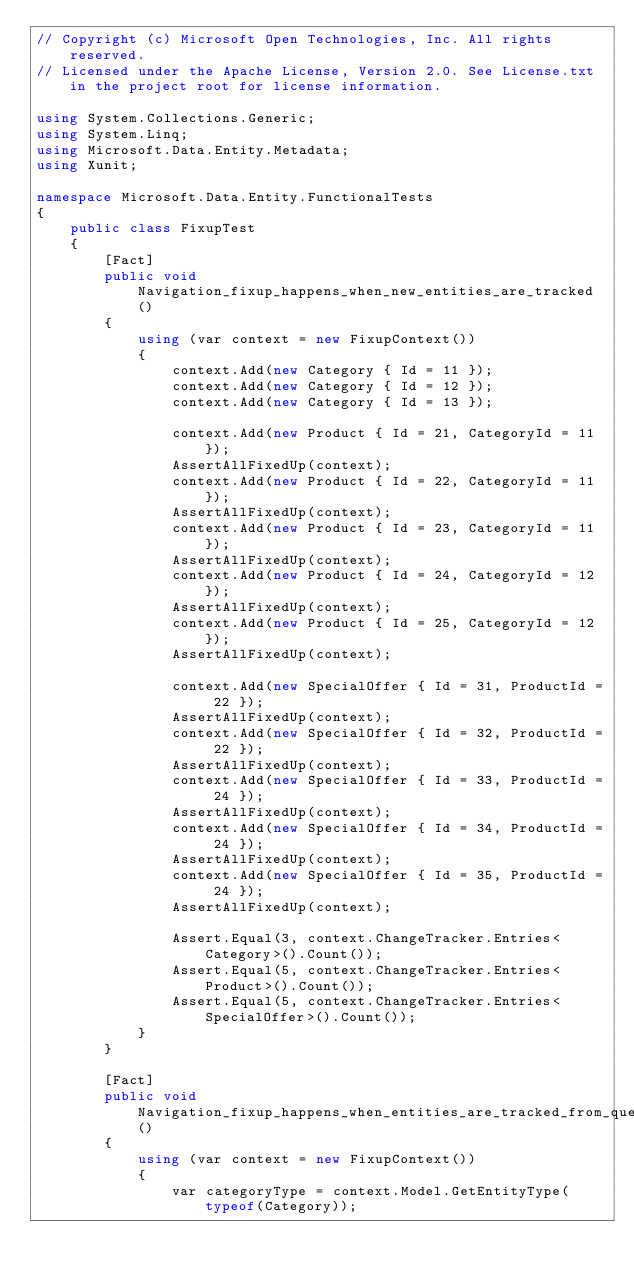Convert code to text. <code><loc_0><loc_0><loc_500><loc_500><_C#_>// Copyright (c) Microsoft Open Technologies, Inc. All rights reserved.
// Licensed under the Apache License, Version 2.0. See License.txt in the project root for license information.

using System.Collections.Generic;
using System.Linq;
using Microsoft.Data.Entity.Metadata;
using Xunit;

namespace Microsoft.Data.Entity.FunctionalTests
{
    public class FixupTest
    {
        [Fact]
        public void Navigation_fixup_happens_when_new_entities_are_tracked()
        {
            using (var context = new FixupContext())
            {
                context.Add(new Category { Id = 11 });
                context.Add(new Category { Id = 12 });
                context.Add(new Category { Id = 13 });

                context.Add(new Product { Id = 21, CategoryId = 11 });
                AssertAllFixedUp(context);
                context.Add(new Product { Id = 22, CategoryId = 11 });
                AssertAllFixedUp(context);
                context.Add(new Product { Id = 23, CategoryId = 11 });
                AssertAllFixedUp(context);
                context.Add(new Product { Id = 24, CategoryId = 12 });
                AssertAllFixedUp(context);
                context.Add(new Product { Id = 25, CategoryId = 12 });
                AssertAllFixedUp(context);

                context.Add(new SpecialOffer { Id = 31, ProductId = 22 });
                AssertAllFixedUp(context);
                context.Add(new SpecialOffer { Id = 32, ProductId = 22 });
                AssertAllFixedUp(context);
                context.Add(new SpecialOffer { Id = 33, ProductId = 24 });
                AssertAllFixedUp(context);
                context.Add(new SpecialOffer { Id = 34, ProductId = 24 });
                AssertAllFixedUp(context);
                context.Add(new SpecialOffer { Id = 35, ProductId = 24 });
                AssertAllFixedUp(context);

                Assert.Equal(3, context.ChangeTracker.Entries<Category>().Count());
                Assert.Equal(5, context.ChangeTracker.Entries<Product>().Count());
                Assert.Equal(5, context.ChangeTracker.Entries<SpecialOffer>().Count());
            }
        }

        [Fact]
        public void Navigation_fixup_happens_when_entities_are_tracked_from_query()
        {
            using (var context = new FixupContext())
            {
                var categoryType = context.Model.GetEntityType(typeof(Category));</code> 